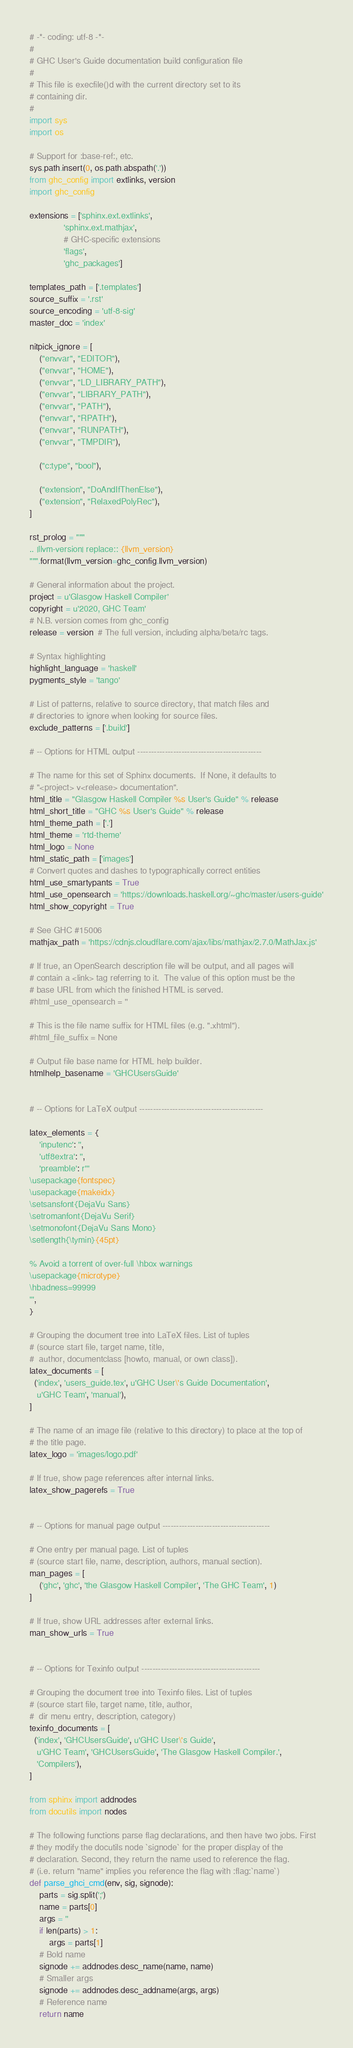Convert code to text. <code><loc_0><loc_0><loc_500><loc_500><_Python_># -*- coding: utf-8 -*-
#
# GHC User's Guide documentation build configuration file
#
# This file is execfile()d with the current directory set to its
# containing dir.
#
import sys
import os

# Support for :base-ref:, etc.
sys.path.insert(0, os.path.abspath('.'))
from ghc_config import extlinks, version
import ghc_config

extensions = ['sphinx.ext.extlinks',
              'sphinx.ext.mathjax',
              # GHC-specific extensions
              'flags',
              'ghc_packages']

templates_path = ['.templates']
source_suffix = '.rst'
source_encoding = 'utf-8-sig'
master_doc = 'index'

nitpick_ignore = [
    ("envvar", "EDITOR"),
    ("envvar", "HOME"),
    ("envvar", "LD_LIBRARY_PATH"),
    ("envvar", "LIBRARY_PATH"),
    ("envvar", "PATH"),
    ("envvar", "RPATH"),
    ("envvar", "RUNPATH"),
    ("envvar", "TMPDIR"),

    ("c:type", "bool"),

    ("extension", "DoAndIfThenElse"),
    ("extension", "RelaxedPolyRec"),
]

rst_prolog = """
.. |llvm-version| replace:: {llvm_version}
""".format(llvm_version=ghc_config.llvm_version)

# General information about the project.
project = u'Glasgow Haskell Compiler'
copyright = u'2020, GHC Team'
# N.B. version comes from ghc_config
release = version  # The full version, including alpha/beta/rc tags.

# Syntax highlighting
highlight_language = 'haskell'
pygments_style = 'tango'

# List of patterns, relative to source directory, that match files and
# directories to ignore when looking for source files.
exclude_patterns = ['.build']

# -- Options for HTML output ---------------------------------------------

# The name for this set of Sphinx documents.  If None, it defaults to
# "<project> v<release> documentation".
html_title = "Glasgow Haskell Compiler %s User's Guide" % release
html_short_title = "GHC %s User's Guide" % release
html_theme_path = ['.']
html_theme = 'rtd-theme'
html_logo = None
html_static_path = ['images']
# Convert quotes and dashes to typographically correct entities
html_use_smartypants = True
html_use_opensearch = 'https://downloads.haskell.org/~ghc/master/users-guide'
html_show_copyright = True

# See GHC #15006
mathjax_path = 'https://cdnjs.cloudflare.com/ajax/libs/mathjax/2.7.0/MathJax.js'

# If true, an OpenSearch description file will be output, and all pages will
# contain a <link> tag referring to it.  The value of this option must be the
# base URL from which the finished HTML is served.
#html_use_opensearch = ''

# This is the file name suffix for HTML files (e.g. ".xhtml").
#html_file_suffix = None

# Output file base name for HTML help builder.
htmlhelp_basename = 'GHCUsersGuide'


# -- Options for LaTeX output ---------------------------------------------

latex_elements = {
    'inputenc': '',
    'utf8extra': '',
    'preamble': r'''
\usepackage{fontspec}
\usepackage{makeidx}
\setsansfont{DejaVu Sans}
\setromanfont{DejaVu Serif}
\setmonofont{DejaVu Sans Mono}
\setlength{\tymin}{45pt}

% Avoid a torrent of over-full \hbox warnings
\usepackage{microtype}
\hbadness=99999
''',
}

# Grouping the document tree into LaTeX files. List of tuples
# (source start file, target name, title,
#  author, documentclass [howto, manual, or own class]).
latex_documents = [
  ('index', 'users_guide.tex', u'GHC User\'s Guide Documentation',
   u'GHC Team', 'manual'),
]

# The name of an image file (relative to this directory) to place at the top of
# the title page.
latex_logo = 'images/logo.pdf'

# If true, show page references after internal links.
latex_show_pagerefs = True


# -- Options for manual page output ---------------------------------------

# One entry per manual page. List of tuples
# (source start file, name, description, authors, manual section).
man_pages = [
    ('ghc', 'ghc', 'the Glasgow Haskell Compiler', 'The GHC Team', 1)
]

# If true, show URL addresses after external links.
man_show_urls = True


# -- Options for Texinfo output -------------------------------------------

# Grouping the document tree into Texinfo files. List of tuples
# (source start file, target name, title, author,
#  dir menu entry, description, category)
texinfo_documents = [
  ('index', 'GHCUsersGuide', u'GHC User\'s Guide',
   u'GHC Team', 'GHCUsersGuide', 'The Glasgow Haskell Compiler.',
   'Compilers'),
]

from sphinx import addnodes
from docutils import nodes

# The following functions parse flag declarations, and then have two jobs. First
# they modify the docutils node `signode` for the proper display of the
# declaration. Second, they return the name used to reference the flag.
# (i.e. return "name" implies you reference the flag with :flag:`name`)
def parse_ghci_cmd(env, sig, signode):
    parts = sig.split(';')
    name = parts[0]
    args = ''
    if len(parts) > 1:
        args = parts[1]
    # Bold name
    signode += addnodes.desc_name(name, name)
    # Smaller args
    signode += addnodes.desc_addname(args, args)
    # Reference name
    return name
</code> 